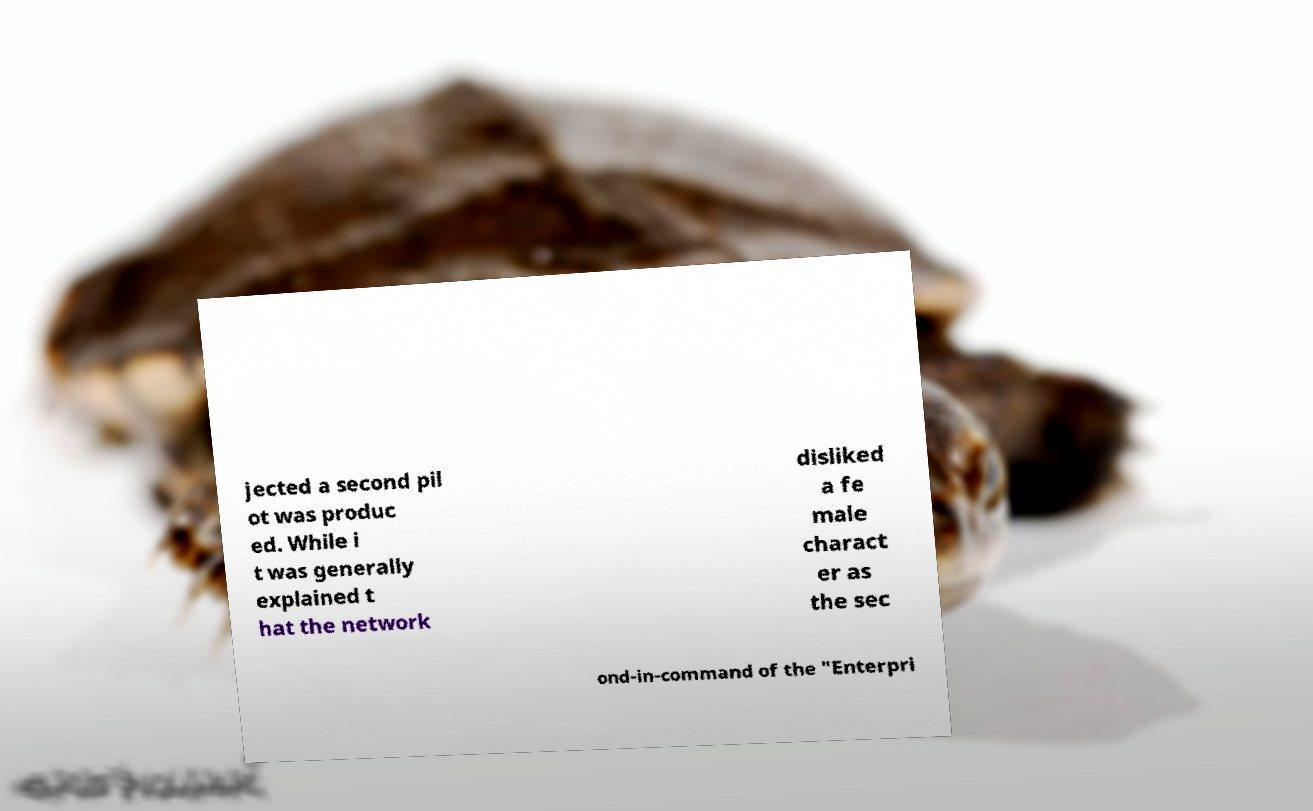What messages or text are displayed in this image? I need them in a readable, typed format. jected a second pil ot was produc ed. While i t was generally explained t hat the network disliked a fe male charact er as the sec ond-in-command of the "Enterpri 